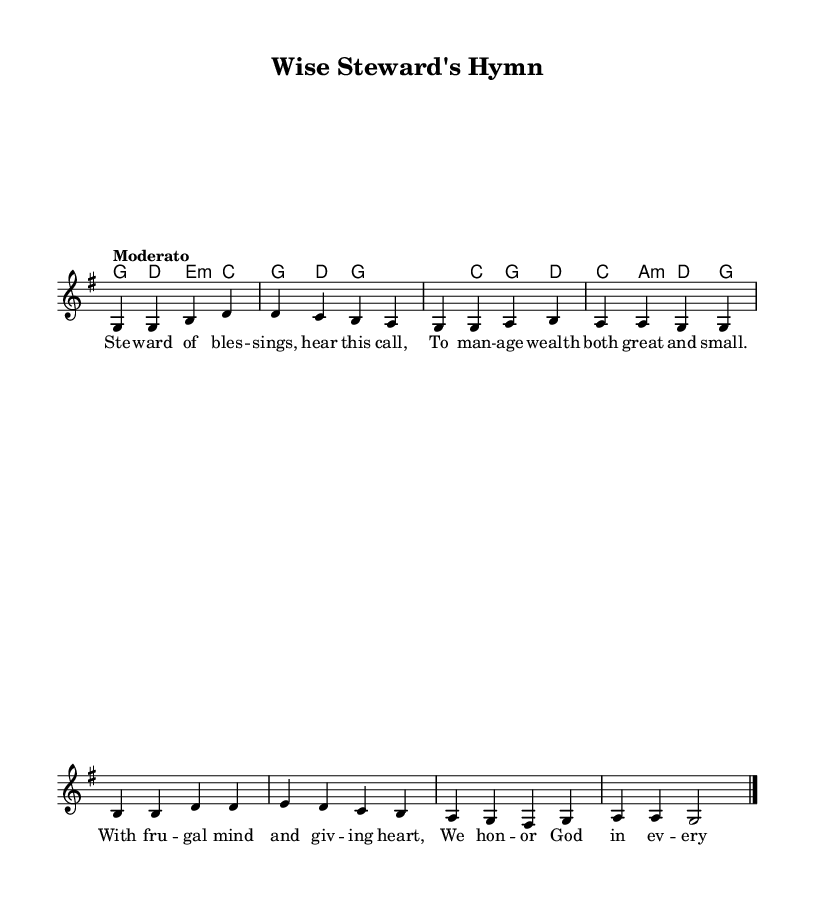What is the key signature of this music? The key signature is G major, which has one sharp (F#).
Answer: G major What is the time signature of this piece? The time signature is indicated as 4/4, meaning there are four beats per measure.
Answer: 4/4 What is the tempo marking for this song? The tempo marking is "Moderato", which means moderate speed.
Answer: Moderato How many lines of lyrics are there in the melody? There are four lines of lyrics in the melody indicated by separate phrases.
Answer: Four Which chord appears first in the harmonies? The first chord listed in the harmonies is G major.
Answer: G How does the theme of stewardship connect to the lyrics? The lyrics emphasize managing wealth wisely and honoring God, which aligns with financial stewardship concepts.
Answer: Managing wealth 